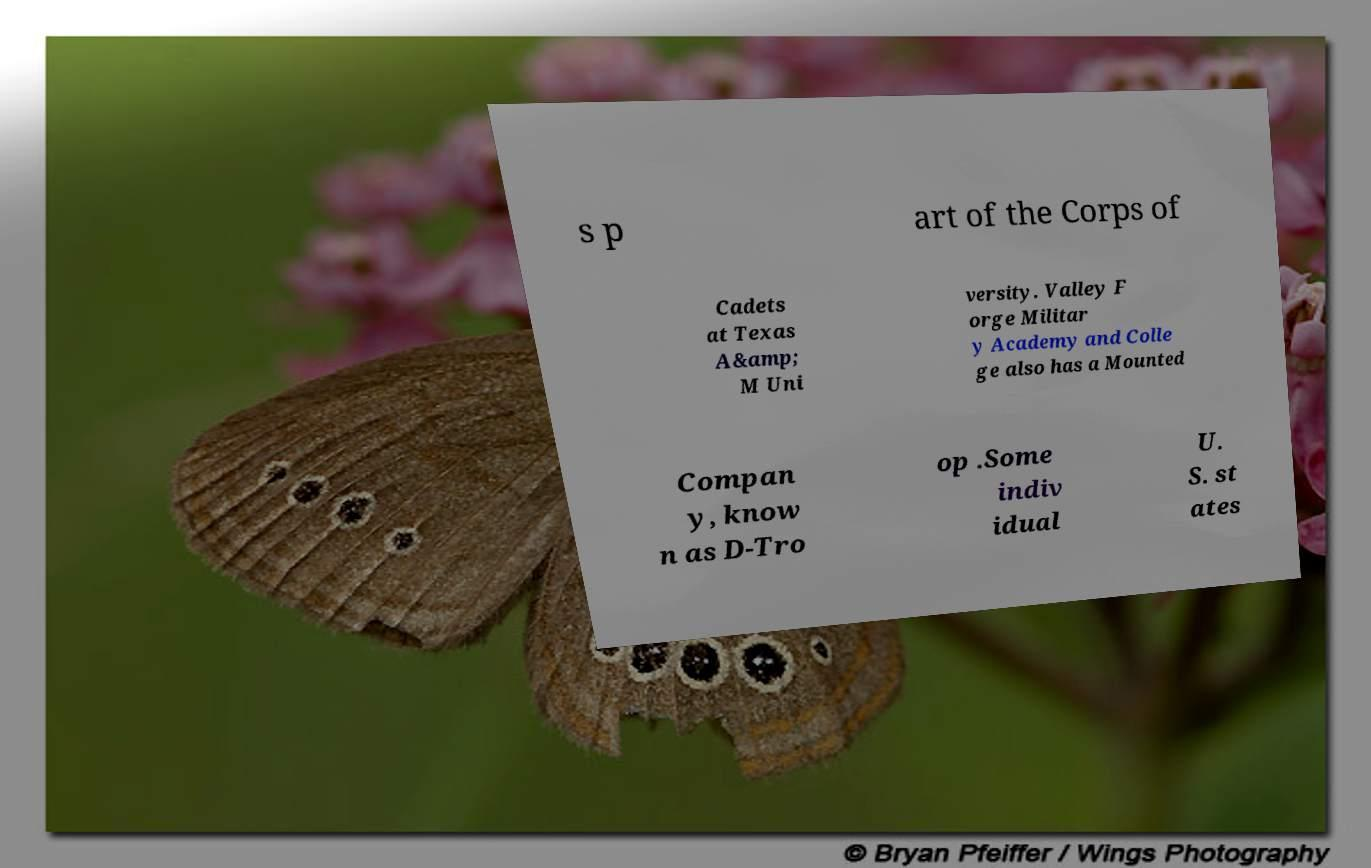There's text embedded in this image that I need extracted. Can you transcribe it verbatim? s p art of the Corps of Cadets at Texas A&amp; M Uni versity. Valley F orge Militar y Academy and Colle ge also has a Mounted Compan y, know n as D-Tro op .Some indiv idual U. S. st ates 